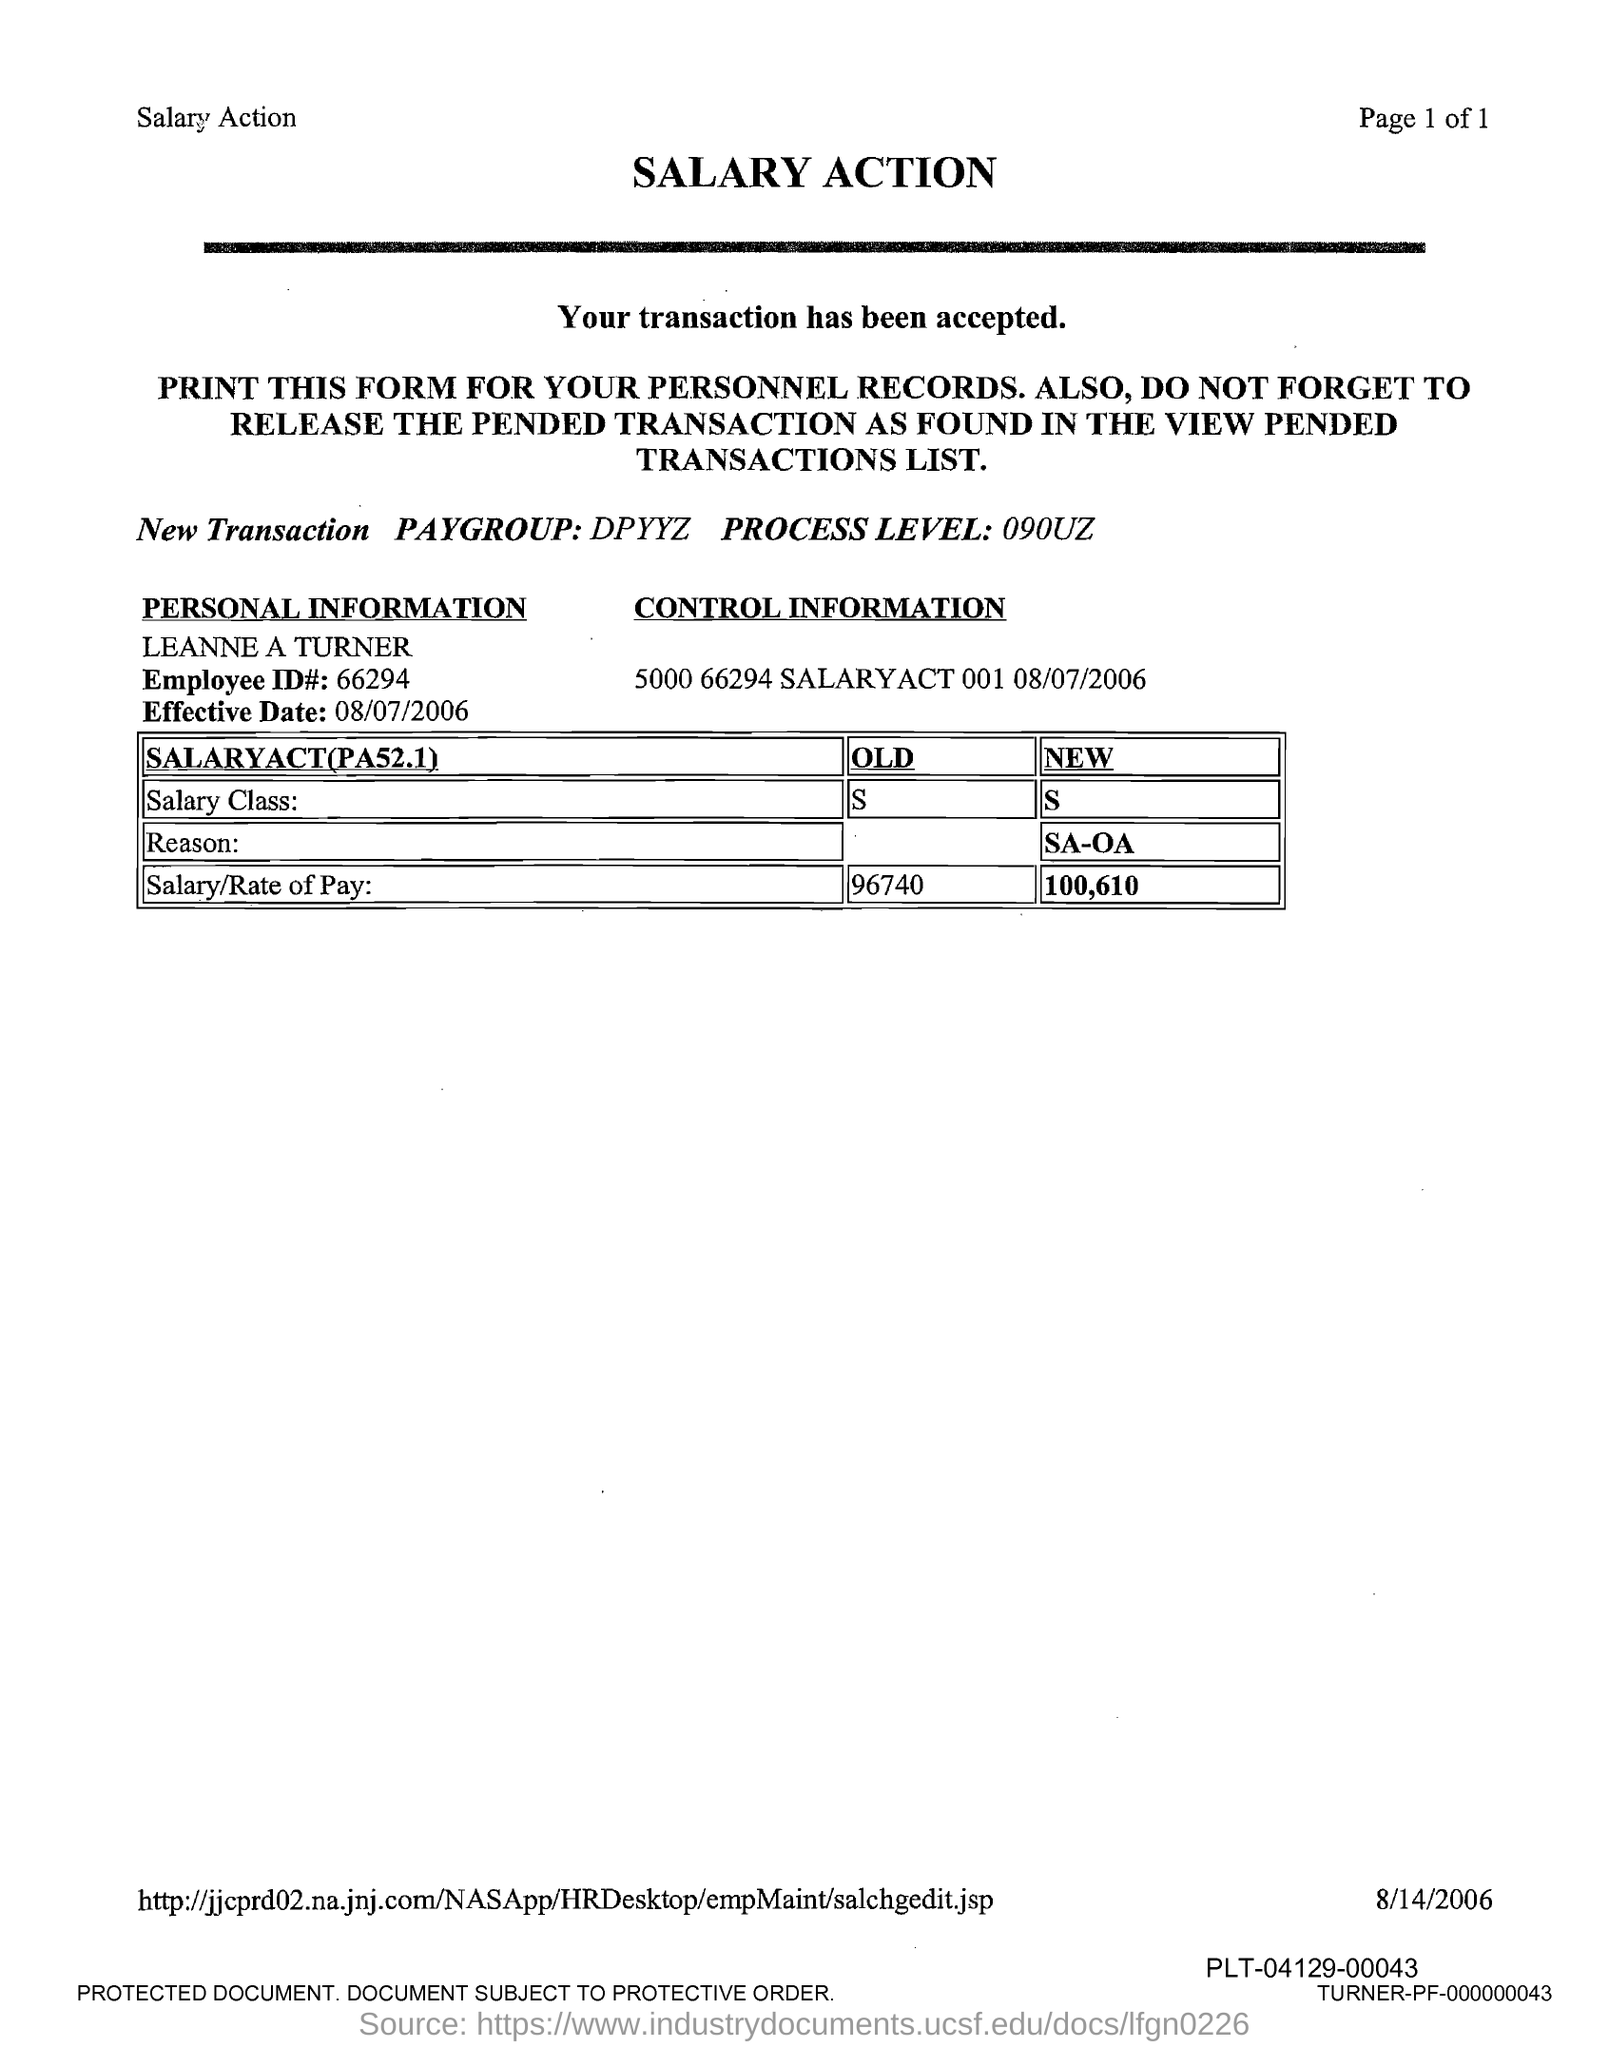Give some essential details in this illustration. The employee ID number is 66294. The title of the document is 'Salary Action.' 